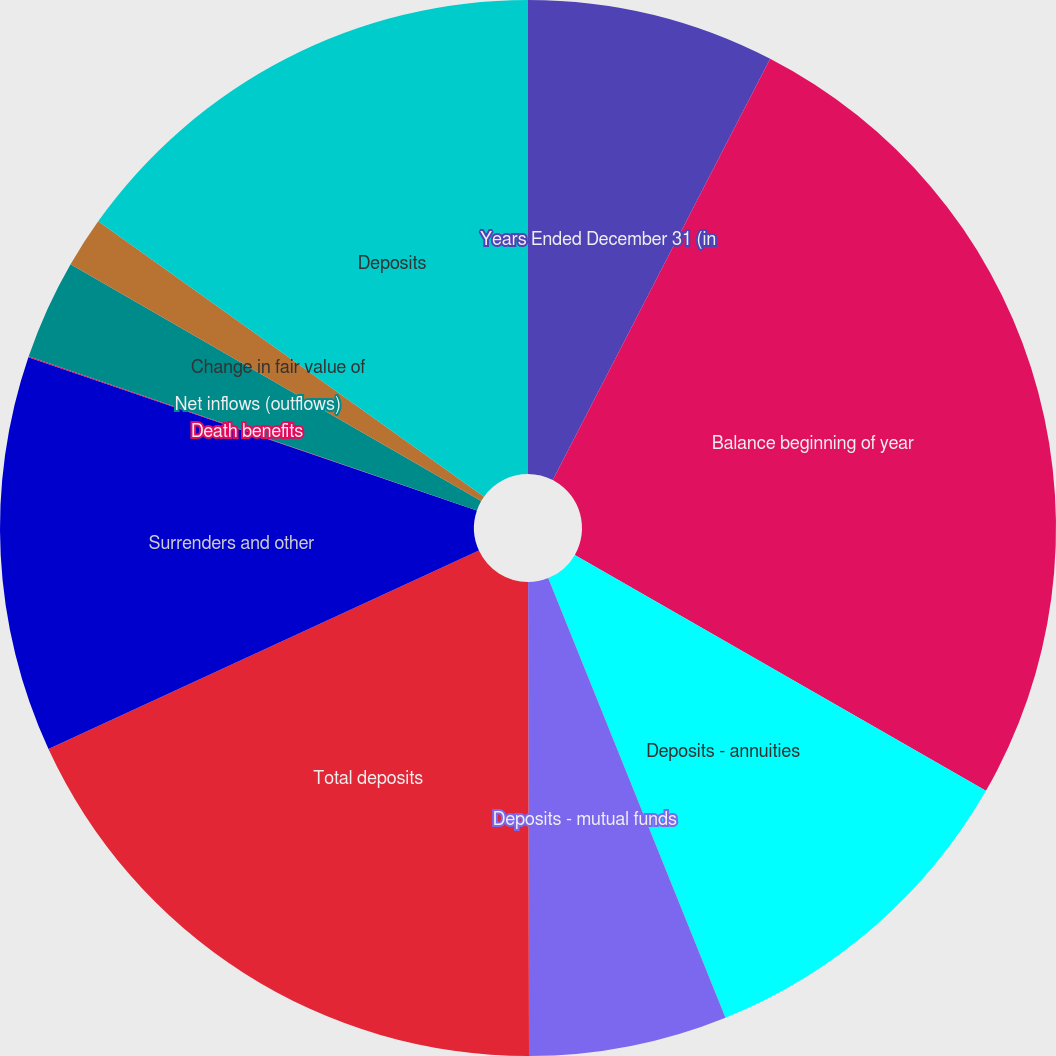Convert chart. <chart><loc_0><loc_0><loc_500><loc_500><pie_chart><fcel>Years Ended December 31 (in<fcel>Balance beginning of year<fcel>Deposits - annuities<fcel>Deposits - mutual funds<fcel>Total deposits<fcel>Surrenders and other<fcel>Death benefits<fcel>Net inflows (outflows)<fcel>Change in fair value of<fcel>Deposits<nl><fcel>7.58%<fcel>25.7%<fcel>10.6%<fcel>6.07%<fcel>18.15%<fcel>12.11%<fcel>0.03%<fcel>3.05%<fcel>1.54%<fcel>15.13%<nl></chart> 